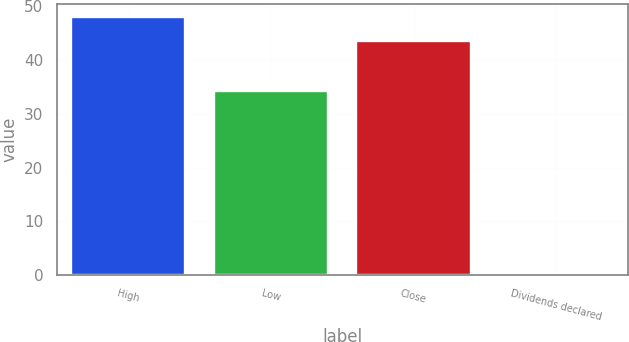Convert chart. <chart><loc_0><loc_0><loc_500><loc_500><bar_chart><fcel>High<fcel>Low<fcel>Close<fcel>Dividends declared<nl><fcel>47.95<fcel>34.27<fcel>43.56<fcel>0.11<nl></chart> 